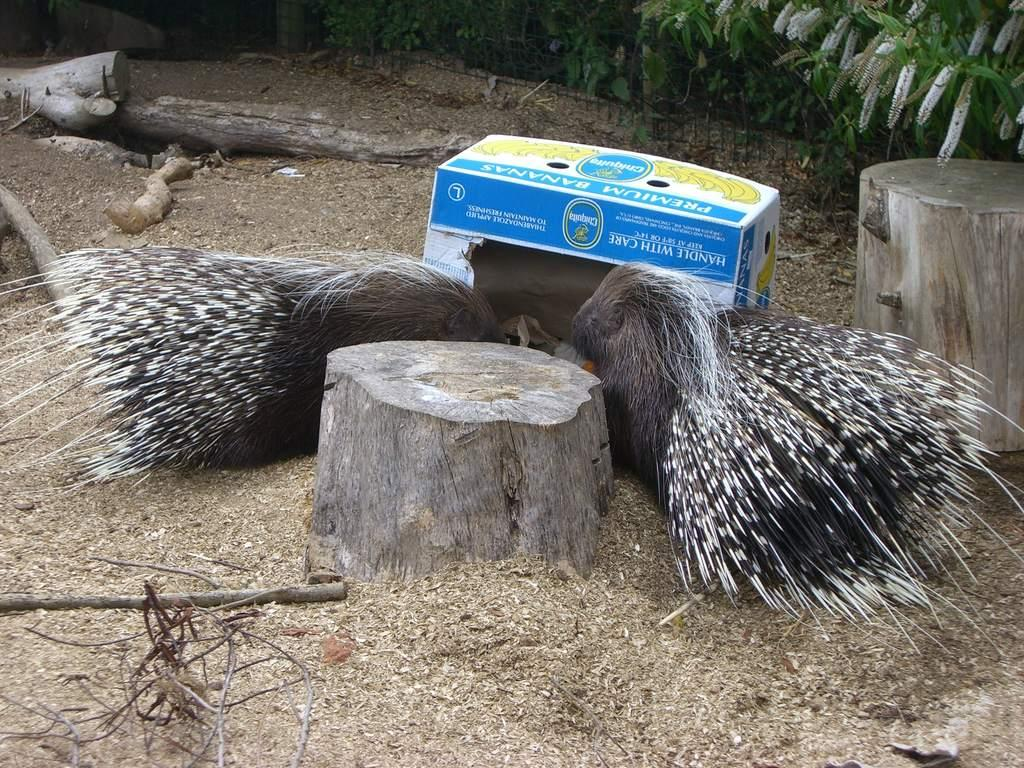What animals are on the ground in the image? There are two porcupines on the ground in the image. What is located behind the porcupines? There is a box behind the porcupines. What type of natural objects can be seen on the ground? There are tree trunks on the ground. What can be seen at the top of the image? There are plants visible at the top of the image. What type of insurance do the porcupines have in the image? There is no mention of insurance in the image, as it features two porcupines, a box, tree trunks, and plants. 